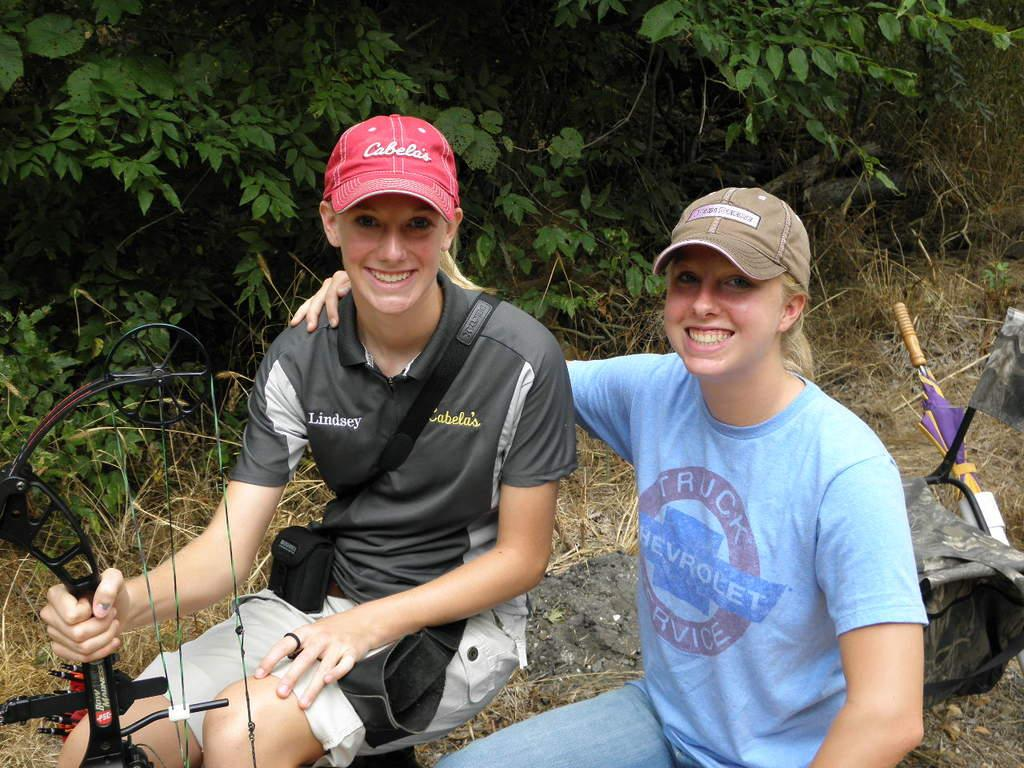How many girls are in the image? There are two girls in the image. What are the girls wearing on their heads? The girls are wearing caps. What are the girls doing in the image? The girls are sitting and smiling. What can be seen near the girls? There is a bag, an arrow, and an umbrella in the image. What is on the ground in the image? There is an object on the ground. What can be seen in the background of the image? There is grass and trees in the background of the image. What type of clover is the girls using to teach the arrow in the image? There is no clover present in the image, and the girls are not teaching the arrow. 